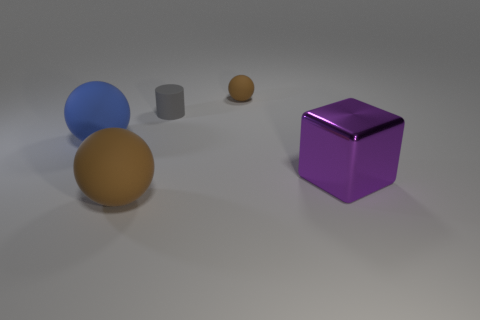Add 1 small blue metallic things. How many objects exist? 6 Subtract all cubes. How many objects are left? 4 Add 1 brown balls. How many brown balls are left? 3 Add 4 large matte things. How many large matte things exist? 6 Subtract 0 yellow blocks. How many objects are left? 5 Subtract all red objects. Subtract all large blocks. How many objects are left? 4 